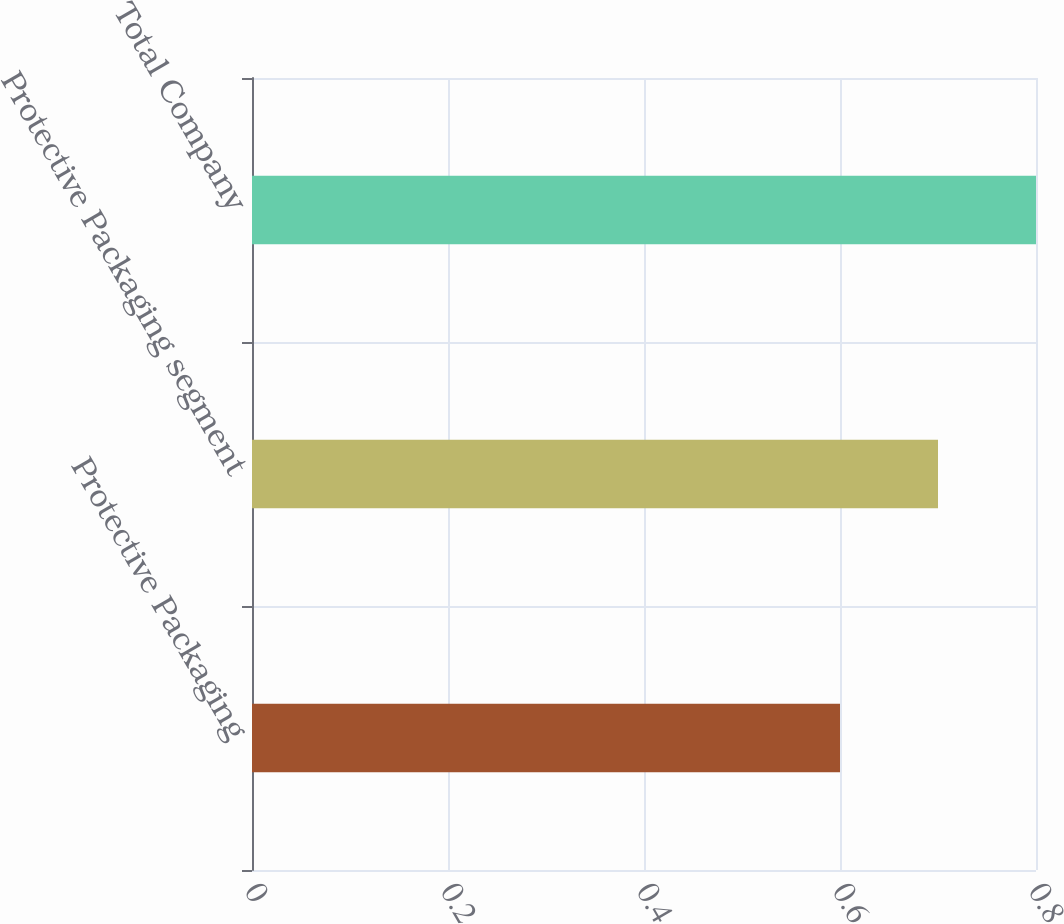Convert chart to OTSL. <chart><loc_0><loc_0><loc_500><loc_500><bar_chart><fcel>Protective Packaging<fcel>Protective Packaging segment<fcel>Total Company<nl><fcel>0.6<fcel>0.7<fcel>0.8<nl></chart> 